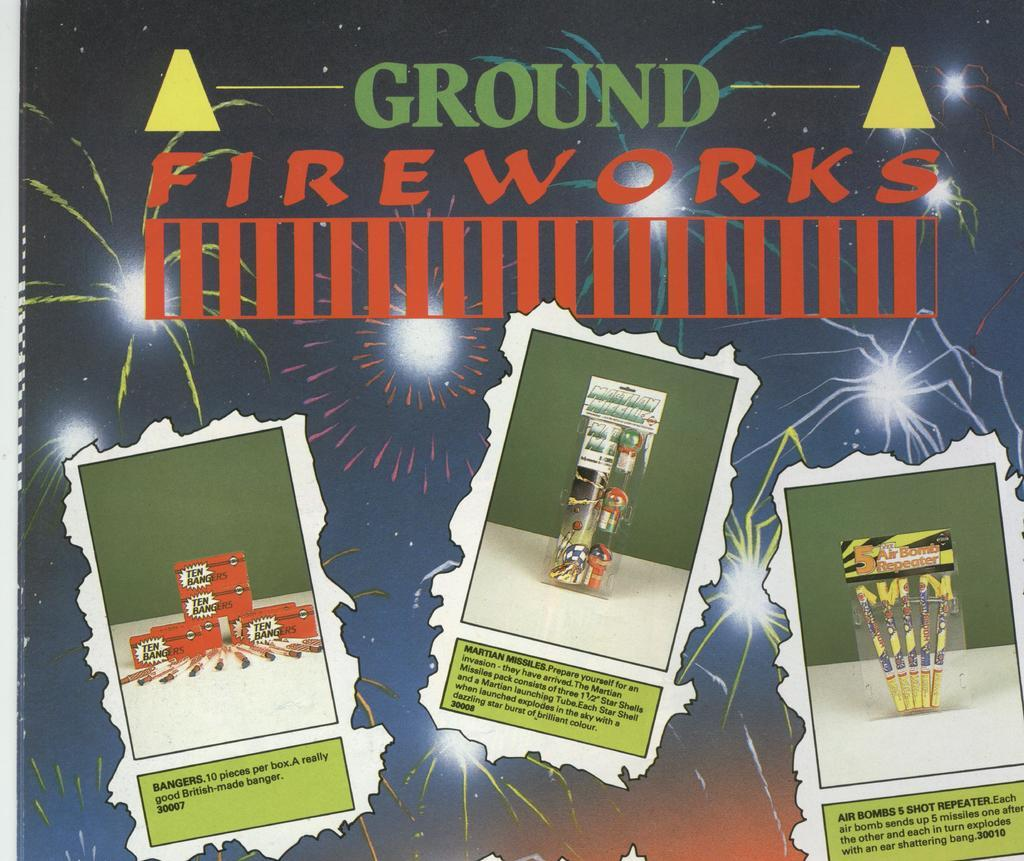<image>
Describe the image concisely. A poster advertises different kind of ground fireworks. 